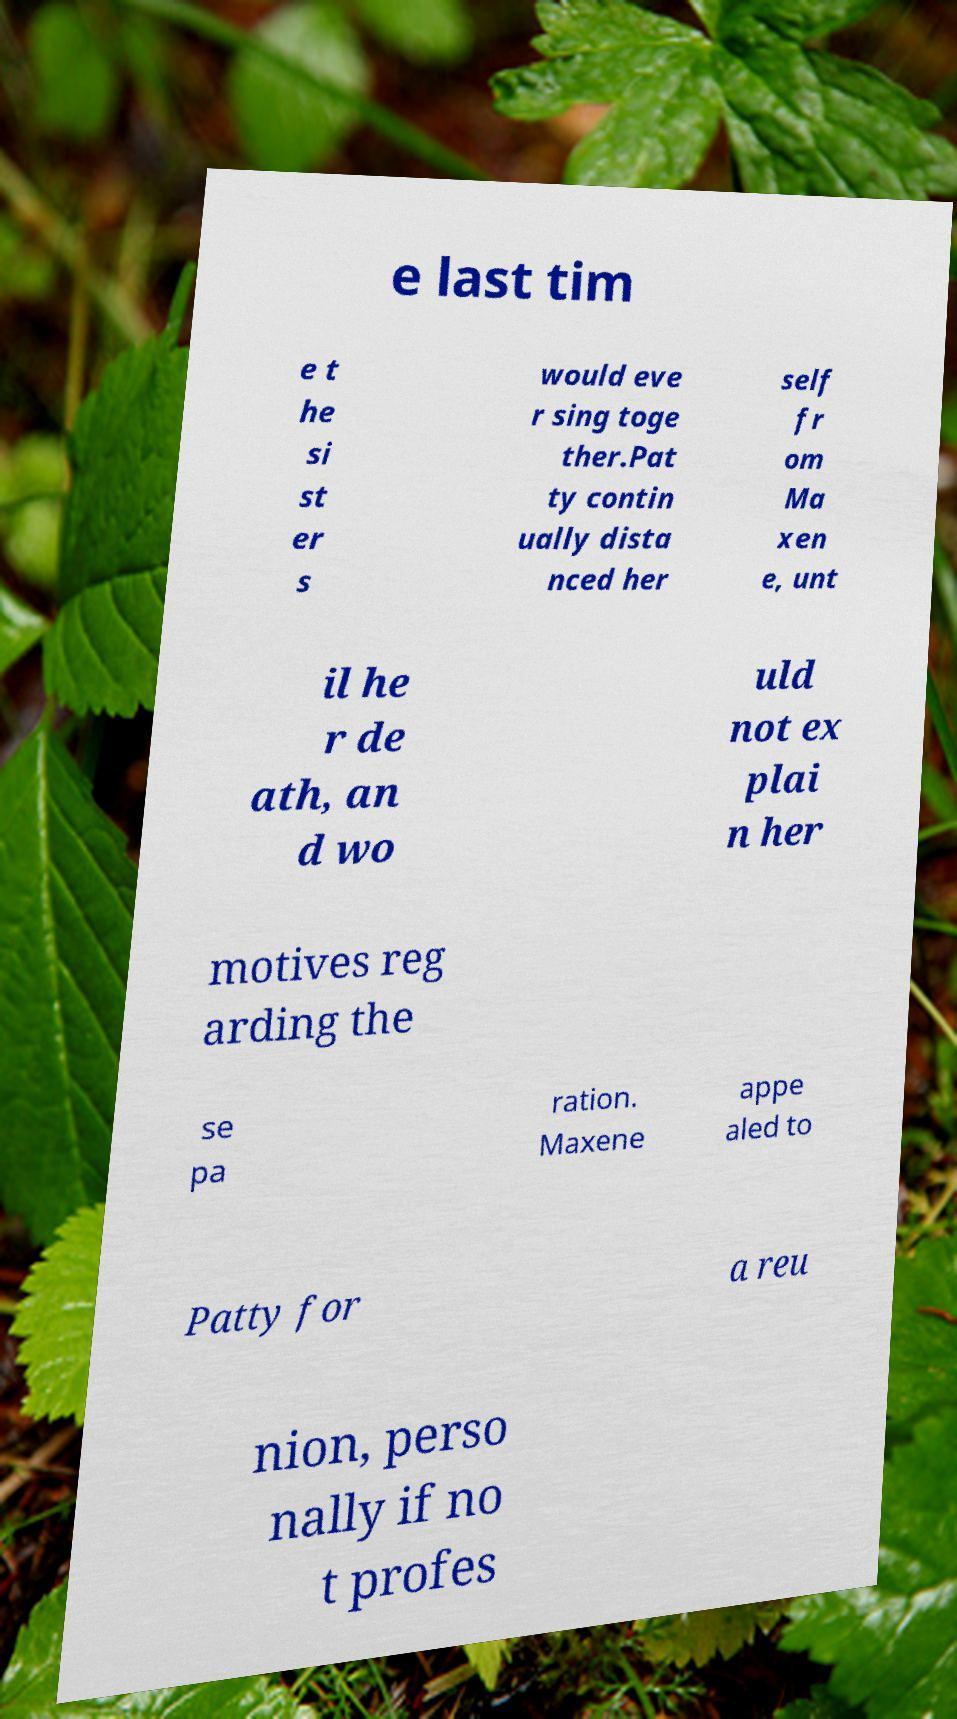Please identify and transcribe the text found in this image. e last tim e t he si st er s would eve r sing toge ther.Pat ty contin ually dista nced her self fr om Ma xen e, unt il he r de ath, an d wo uld not ex plai n her motives reg arding the se pa ration. Maxene appe aled to Patty for a reu nion, perso nally if no t profes 